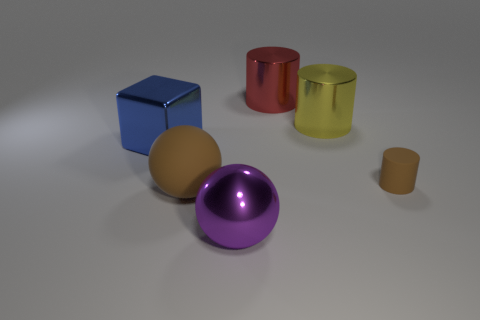What can you tell me about the colors and materials of the objects? The objects presented demonstrate a variety of colors and finishes. The blue cube exhibits a vibrant, glossy finish, while the red cylinder has a similar sheen but in a rich red hue. The yellow cylinder stands out with a reflective metallic surface, suggesting it might be made of a material like gold. The brown ball and the small brown cylinder showcase a matte finish that absorbs light, giving them a more subdued appearance. Lastly, the purple sphere has a reflective quality that suggests a metallic or plastic material with a shiny surface. 